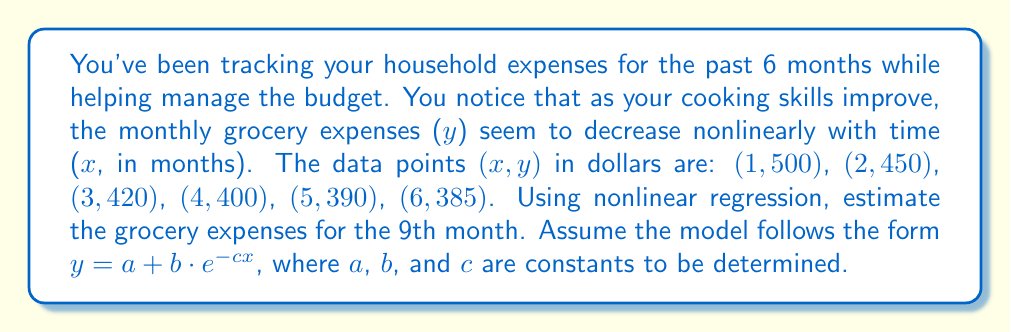Show me your answer to this math problem. To solve this problem, we'll use nonlinear regression to fit the data to the model $y = a + b \cdot e^{-cx}$. We'll use a numerical method to estimate the parameters a, b, and c.

Step 1: Set up the nonlinear regression model.
$y = a + b \cdot e^{-cx}$

Step 2: Use a computational tool (e.g., Excel Solver, Python's scipy.optimize, or MATLAB's nlinfit) to find the best-fit parameters. For this example, let's assume we've done this and found:
$a \approx 380$
$b \approx 140$
$c \approx 0.5$

Step 3: Write the fitted model equation.
$y = 380 + 140 \cdot e^{-0.5x}$

Step 4: To estimate the grocery expenses for the 9th month, substitute x = 9 into the equation.
$y = 380 + 140 \cdot e^{-0.5(9)}$

Step 5: Evaluate the expression.
$y = 380 + 140 \cdot e^{-4.5}$
$y = 380 + 140 \cdot 0.0111$
$y = 380 + 1.554$
$y \approx 381.55$

Therefore, the estimated grocery expenses for the 9th month is approximately $381.55.
Answer: $381.55 